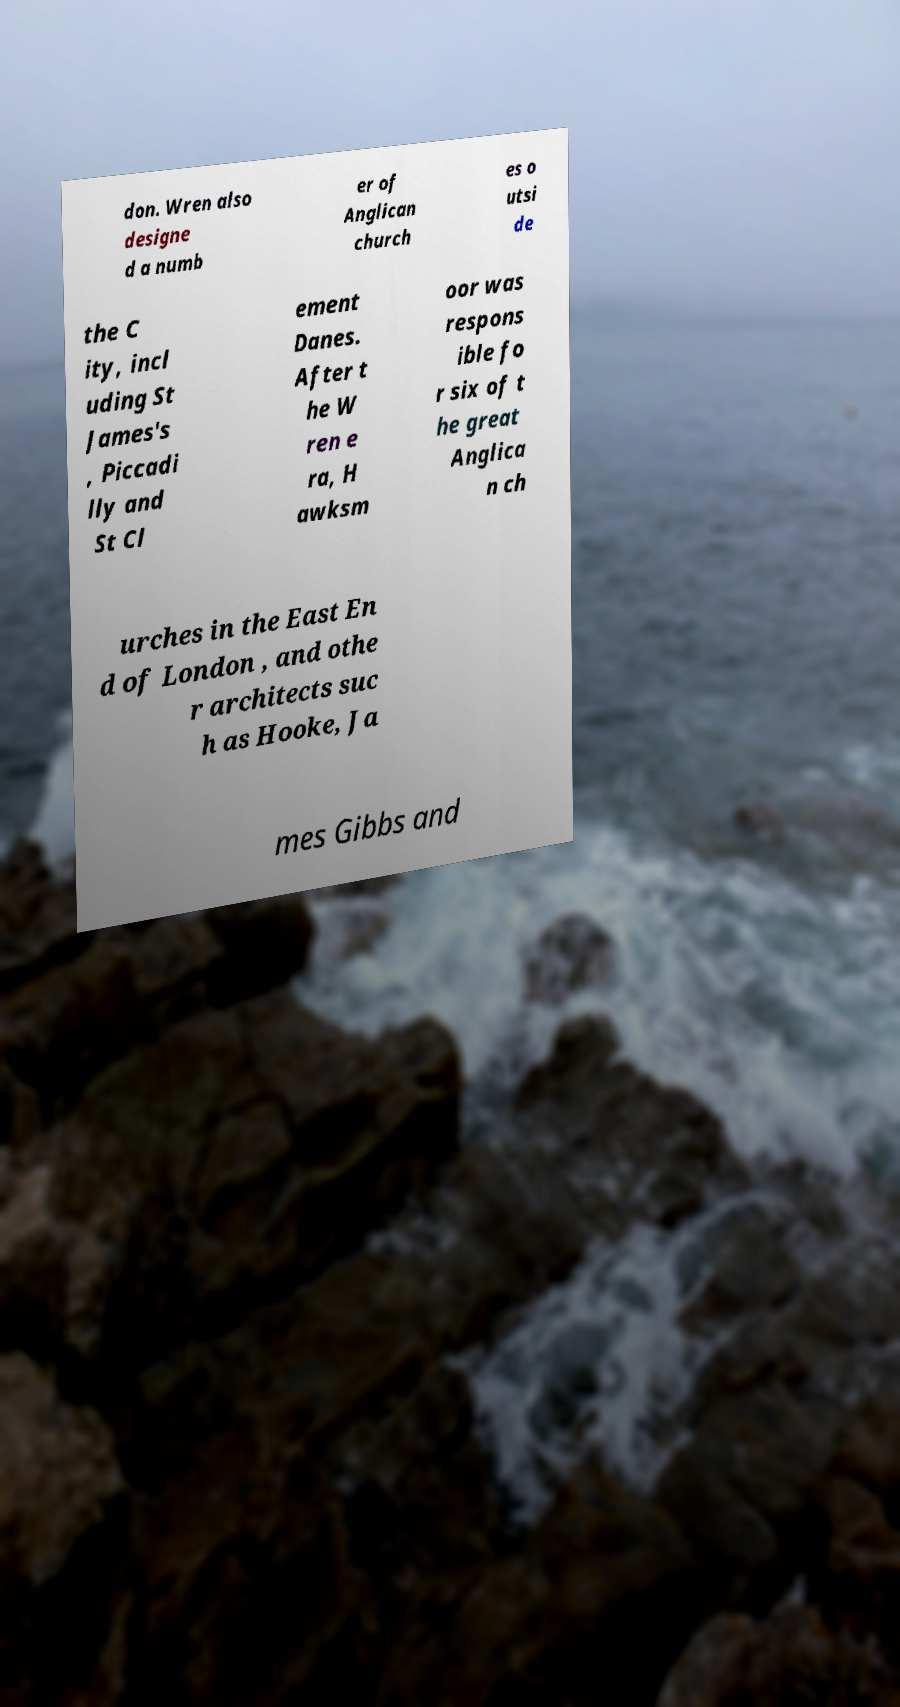There's text embedded in this image that I need extracted. Can you transcribe it verbatim? don. Wren also designe d a numb er of Anglican church es o utsi de the C ity, incl uding St James's , Piccadi lly and St Cl ement Danes. After t he W ren e ra, H awksm oor was respons ible fo r six of t he great Anglica n ch urches in the East En d of London , and othe r architects suc h as Hooke, Ja mes Gibbs and 